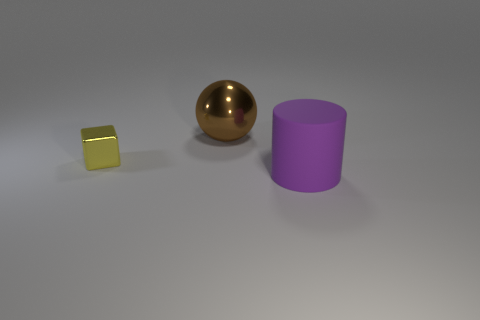Add 3 tiny yellow metallic blocks. How many objects exist? 6 Subtract all cylinders. How many objects are left? 2 Add 2 purple matte objects. How many purple matte objects exist? 3 Subtract 1 yellow blocks. How many objects are left? 2 Subtract all red cylinders. Subtract all gray blocks. How many cylinders are left? 1 Subtract all purple cylinders. Subtract all large purple rubber objects. How many objects are left? 1 Add 1 large purple rubber objects. How many large purple rubber objects are left? 2 